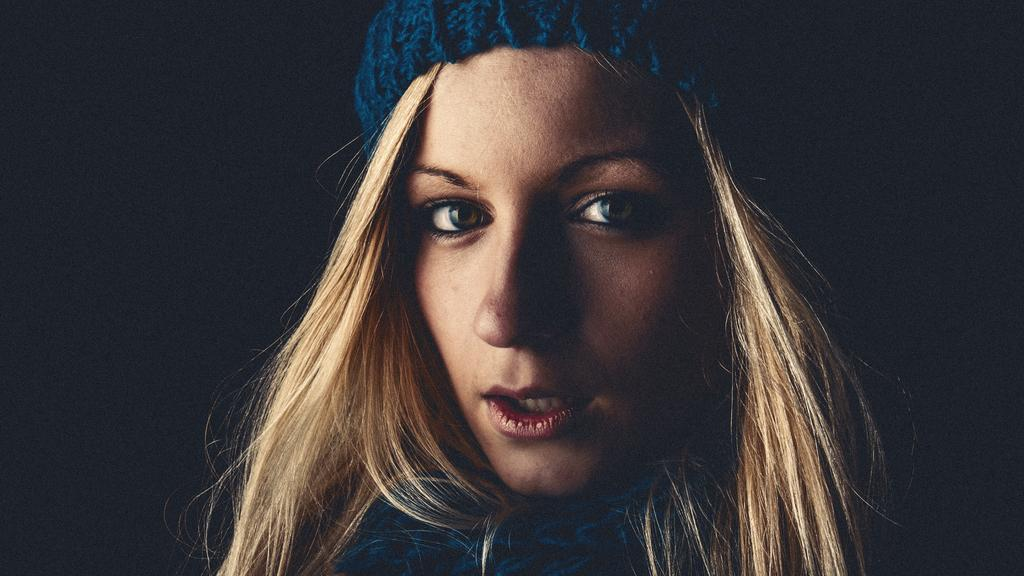Who or what is the main subject in the image? There is a person in the image. What is the person wearing? The person is wearing a blue dress. What color is the background of the image? The background of the image is black. What type of stick can be seen in the person's hand in the image? There is no stick visible in the person's hand in the image. What is the person doing with their back in the image? The person's back is not visible in the image, so it is not possible to determine what they might be doing with it. 